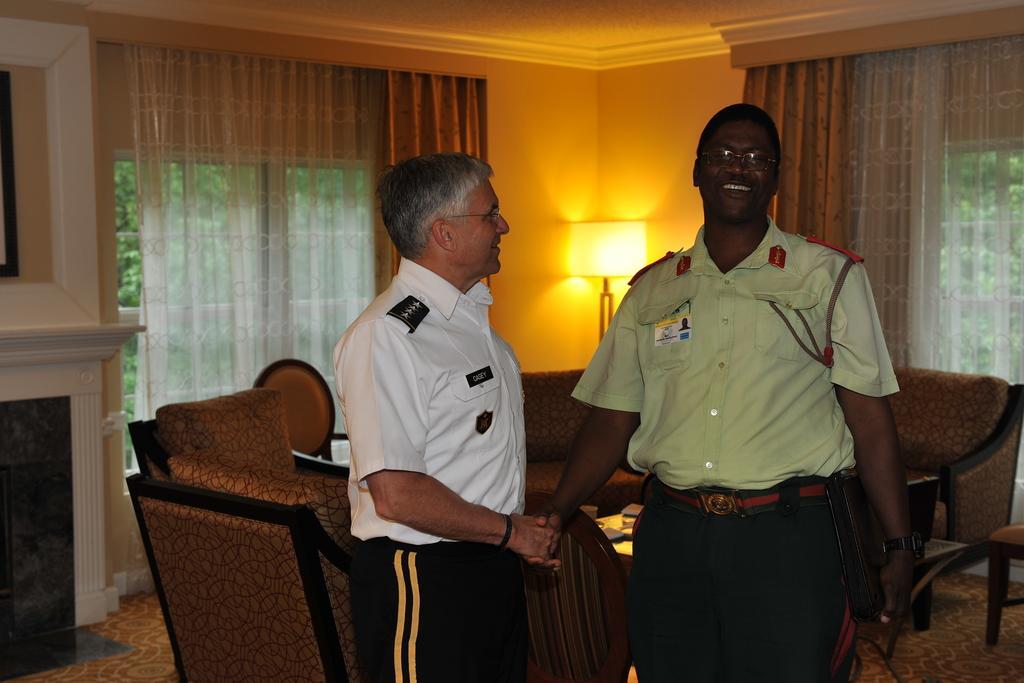In one or two sentences, can you explain what this image depicts? This image is clicked inside a room. There are two persons standing in the middle. There is a sofa in the middle. There are curtains in the middle. There is a lamp in the middle. 